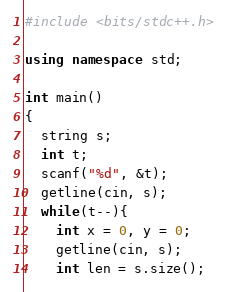Convert code to text. <code><loc_0><loc_0><loc_500><loc_500><_C++_>#include <bits/stdc++.h>

using namespace std;

int main()
{
  string s;
  int t;
  scanf("%d", &t);
  getline(cin, s);
  while(t--){
    int x = 0, y = 0;
    getline(cin, s);
    int len = s.size();</code> 